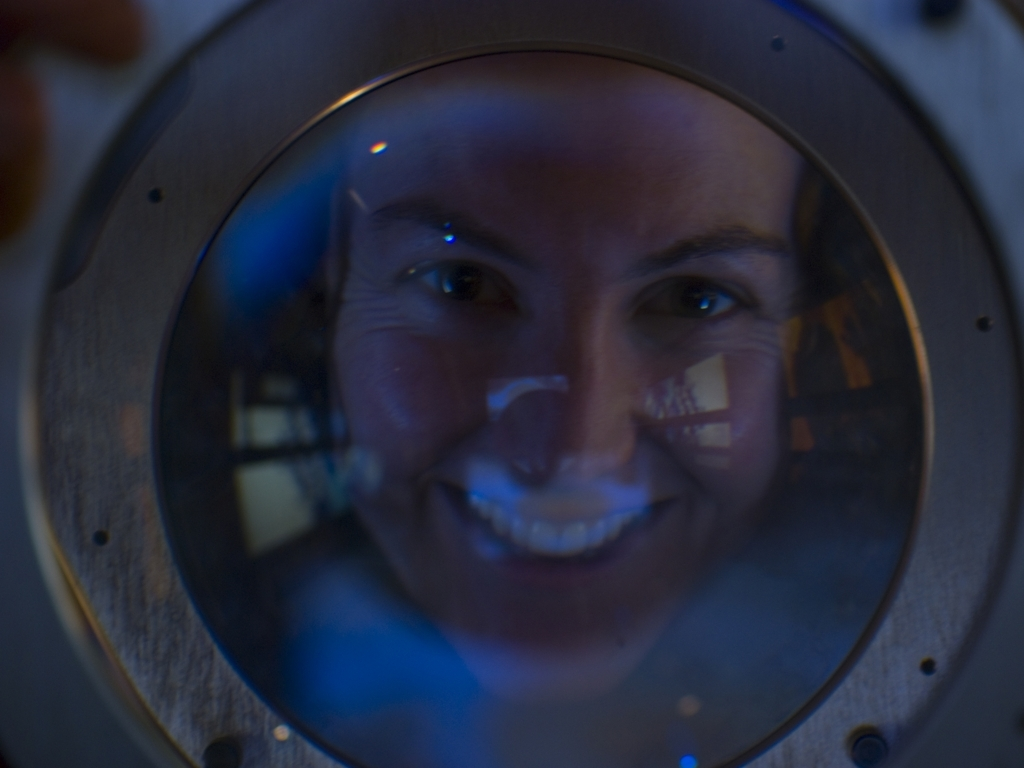What is the mood or atmosphere conveyed by this image? The mood conveyed by this image is somewhat mysterious and introspective. The subdued lighting and the reflection of the face on a curved surface create an intimate and slightly surreal atmosphere. 